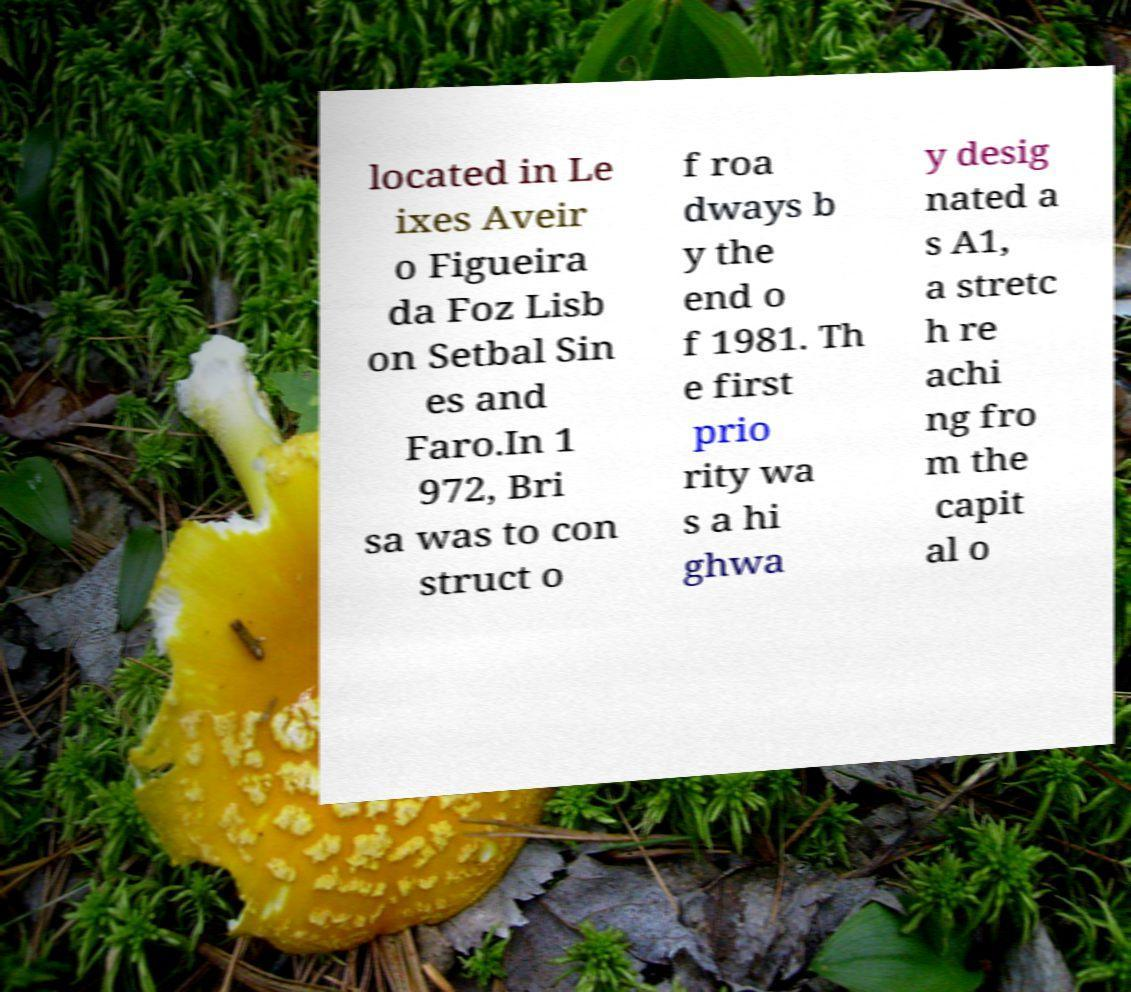For documentation purposes, I need the text within this image transcribed. Could you provide that? located in Le ixes Aveir o Figueira da Foz Lisb on Setbal Sin es and Faro.In 1 972, Bri sa was to con struct o f roa dways b y the end o f 1981. Th e first prio rity wa s a hi ghwa y desig nated a s A1, a stretc h re achi ng fro m the capit al o 